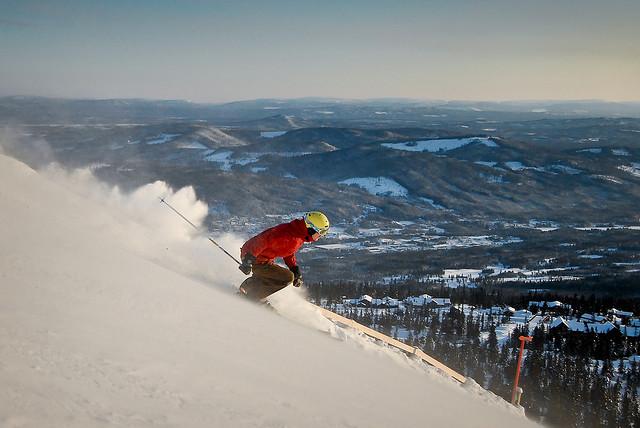What color is his helmet?
Short answer required. Yellow. Is this person snowboarding?
Be succinct. No. What is in his right hand?
Keep it brief. Ski pole. 